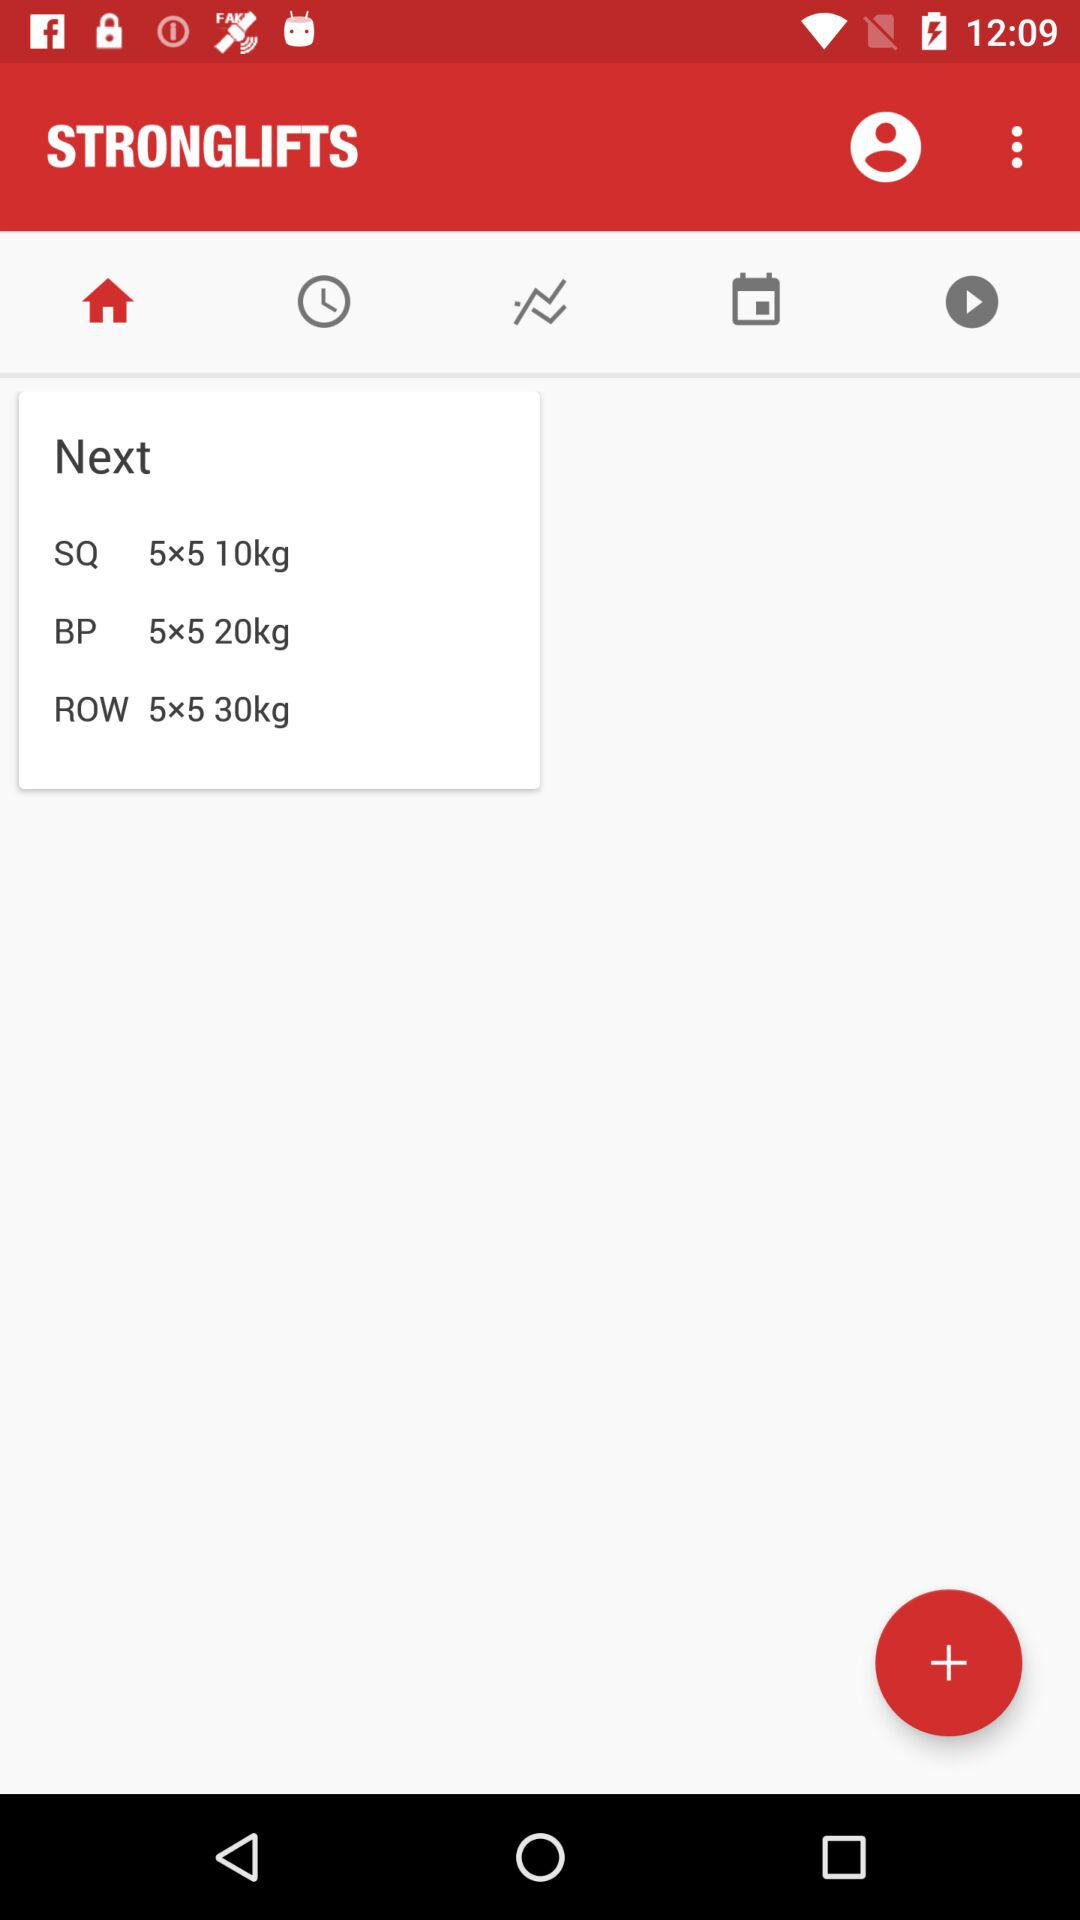What is the name of the application? The name of the application is "STRONGLIFTS". 